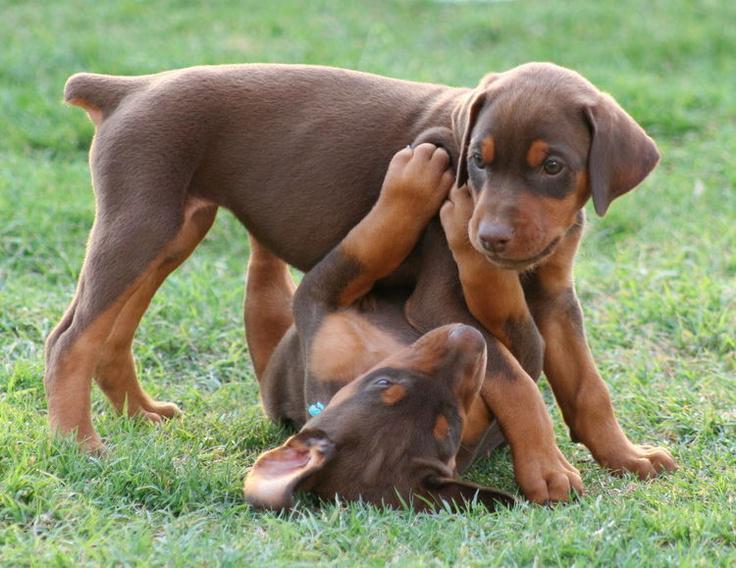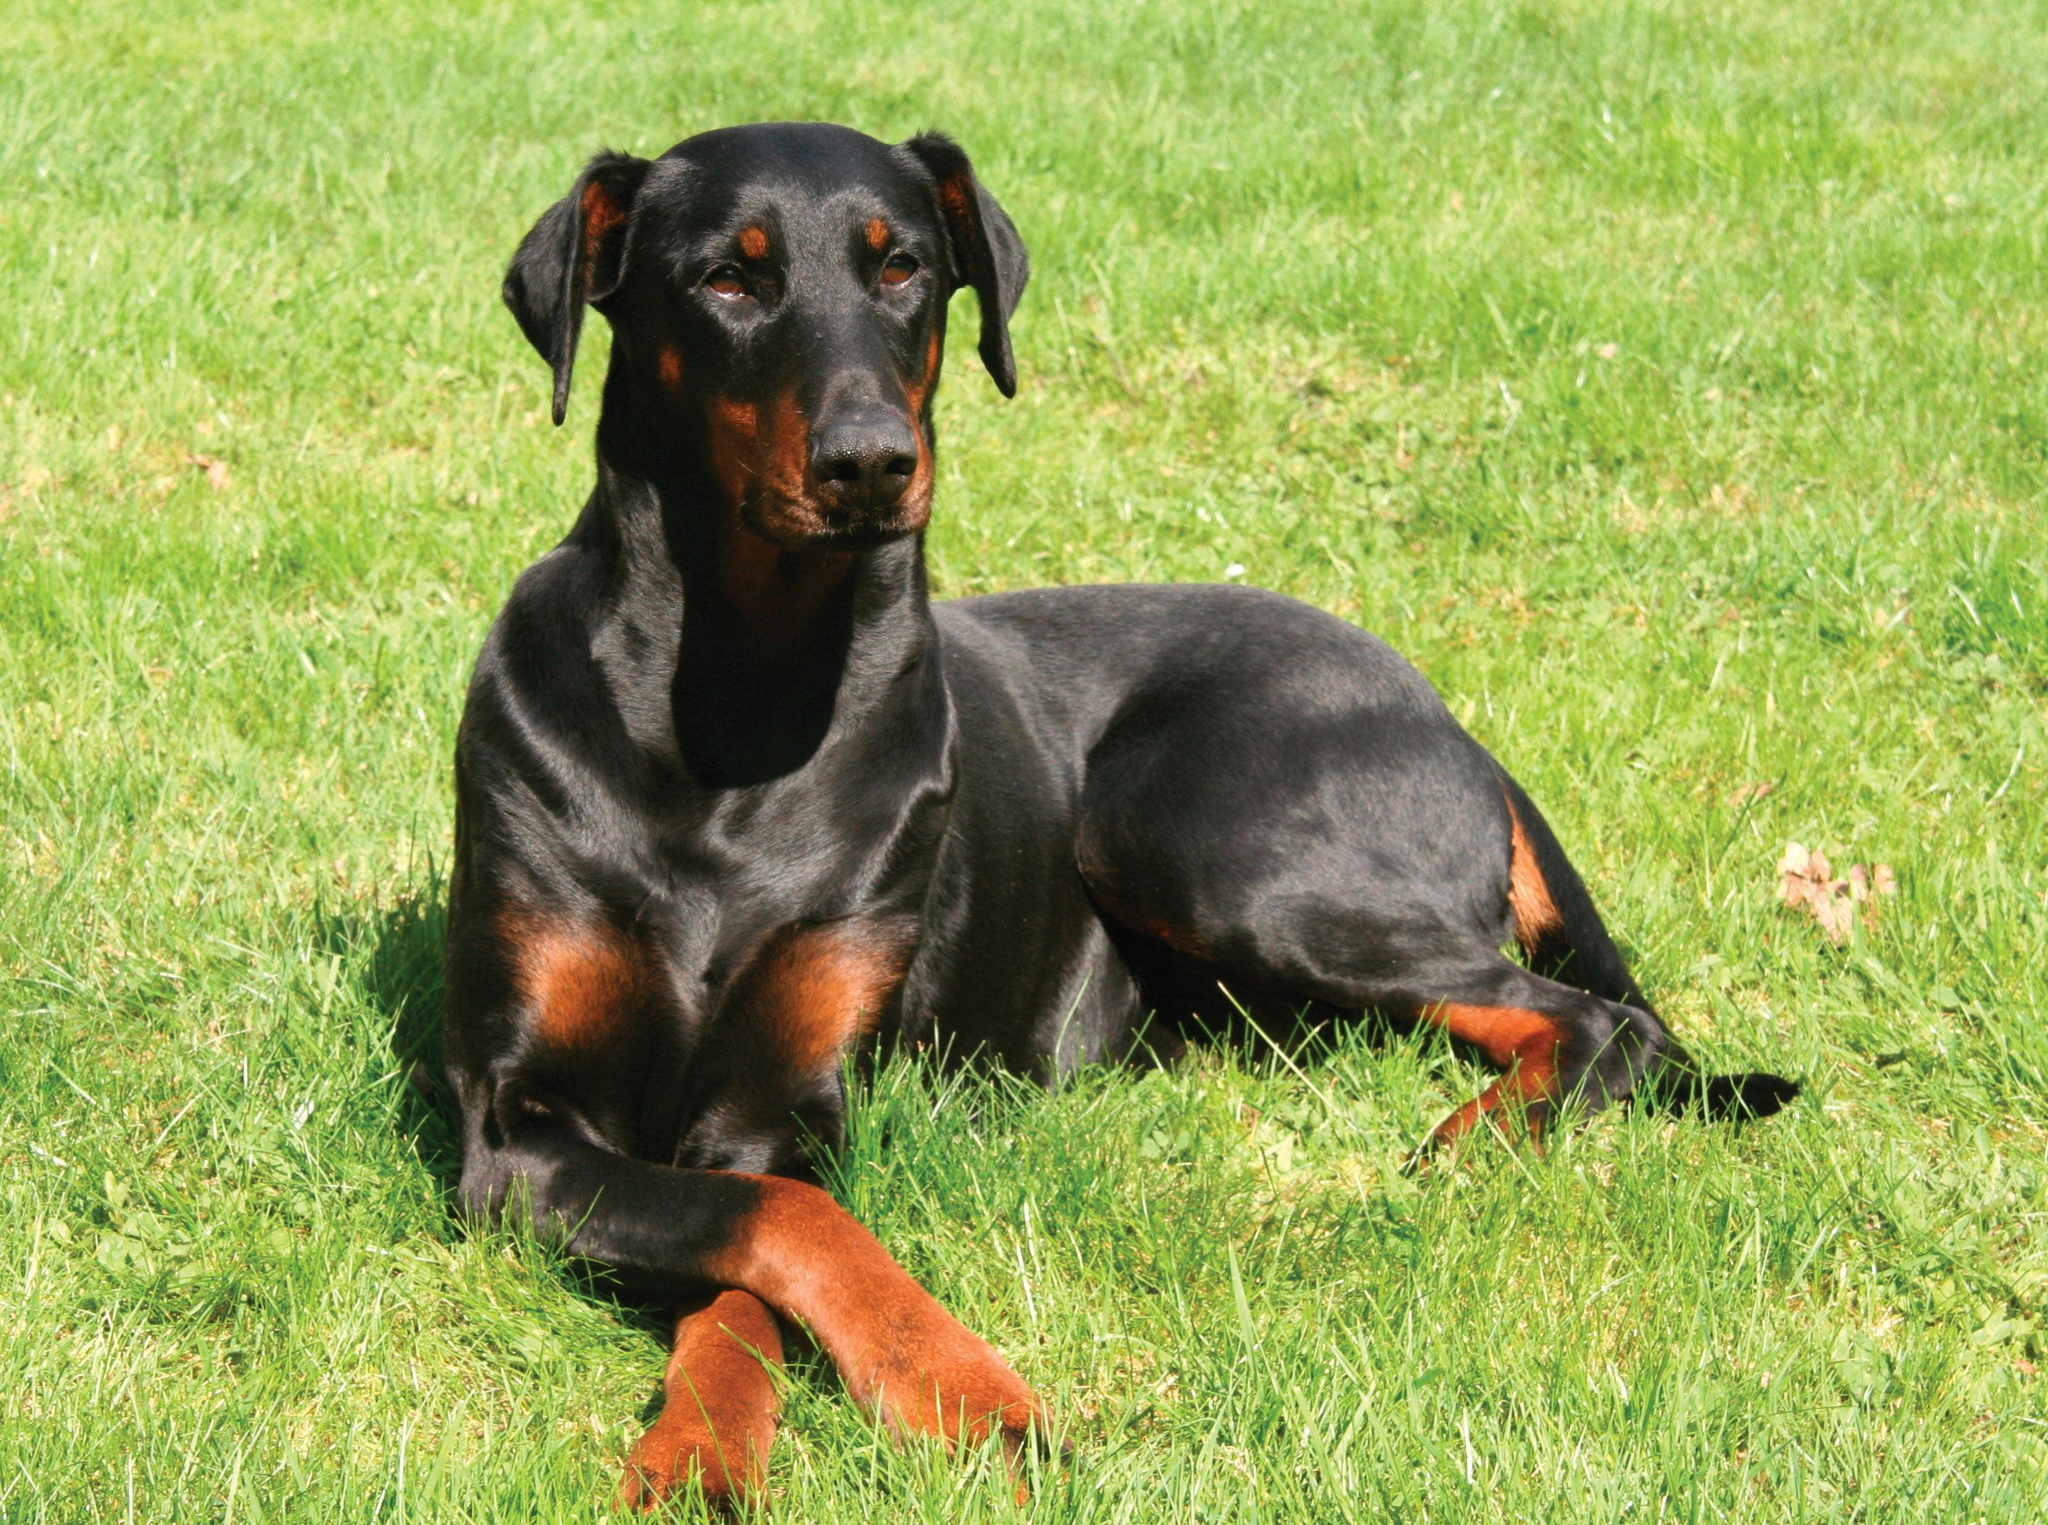The first image is the image on the left, the second image is the image on the right. For the images shown, is this caption "One image shows a single dog lying on grass with its front paws extended and crossed." true? Answer yes or no. Yes. The first image is the image on the left, the second image is the image on the right. Analyze the images presented: Is the assertion "One image contains one pointy-eared doberman in a reclining pose with upright head, and the other image features side-by-side pointy-eared dobermans - one brown and one black-and-tan." valid? Answer yes or no. No. 